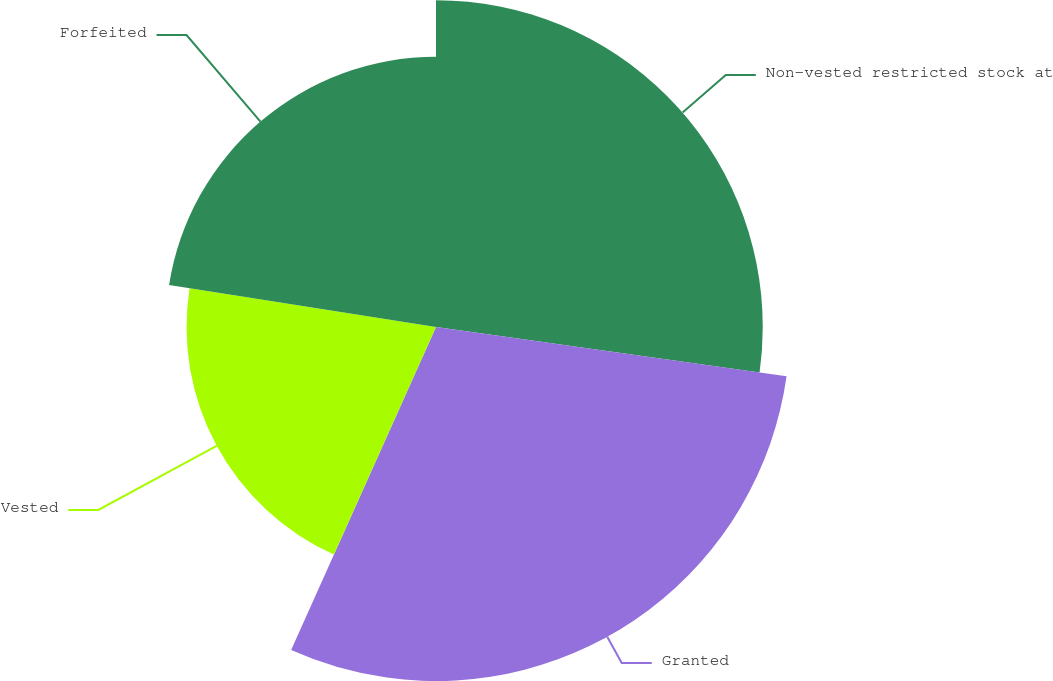Convert chart to OTSL. <chart><loc_0><loc_0><loc_500><loc_500><pie_chart><fcel>Non-vested restricted stock at<fcel>Granted<fcel>Vested<fcel>Forfeited<nl><fcel>27.22%<fcel>29.49%<fcel>20.78%<fcel>22.51%<nl></chart> 